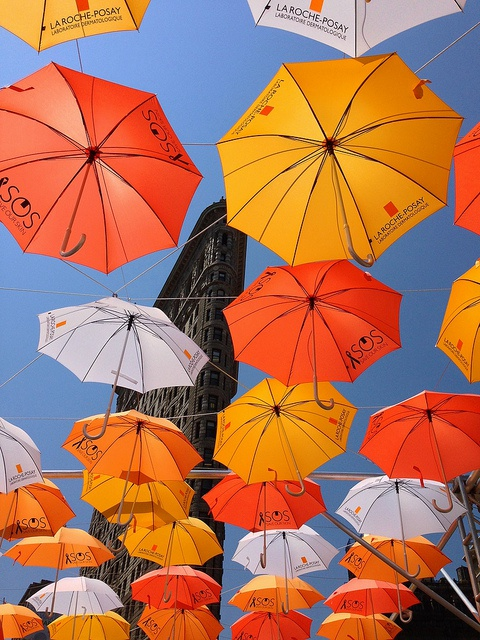Describe the objects in this image and their specific colors. I can see umbrella in gold, orange, brown, and maroon tones, umbrella in gold, salmon, and red tones, umbrella in gold, red, brown, and maroon tones, umbrella in gold, lightgray, and darkgray tones, and umbrella in gold, orange, and brown tones in this image. 